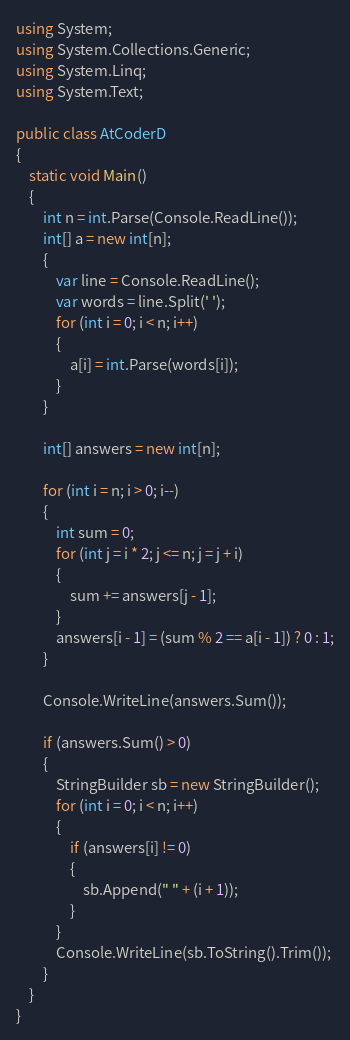Convert code to text. <code><loc_0><loc_0><loc_500><loc_500><_C#_>using System;
using System.Collections.Generic;
using System.Linq;
using System.Text;

public class AtCoderD
{
    static void Main()
    {
        int n = int.Parse(Console.ReadLine());
        int[] a = new int[n];
        {
            var line = Console.ReadLine();
            var words = line.Split(' ');
            for (int i = 0; i < n; i++)
            {
                a[i] = int.Parse(words[i]);
            }
        }

        int[] answers = new int[n];

        for (int i = n; i > 0; i--)
        {
            int sum = 0;
            for (int j = i * 2; j <= n; j = j + i)
            {
                sum += answers[j - 1];
            }
            answers[i - 1] = (sum % 2 == a[i - 1]) ? 0 : 1;
        }

        Console.WriteLine(answers.Sum());

        if (answers.Sum() > 0)
        {
            StringBuilder sb = new StringBuilder();
            for (int i = 0; i < n; i++)
            {
                if (answers[i] != 0)
                {
                    sb.Append(" " + (i + 1));
                }
            }
            Console.WriteLine(sb.ToString().Trim());
        }
    }
}</code> 